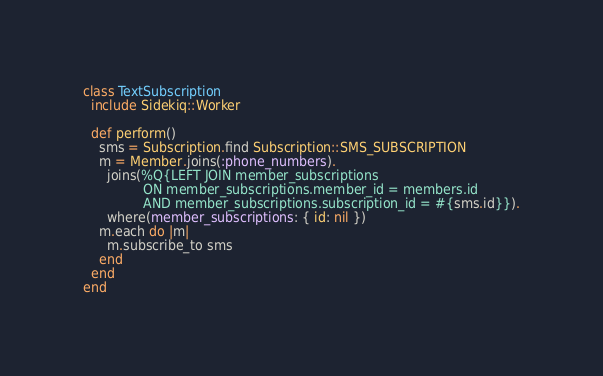Convert code to text. <code><loc_0><loc_0><loc_500><loc_500><_Ruby_>class TextSubscription
  include Sidekiq::Worker

  def perform()
    sms = Subscription.find Subscription::SMS_SUBSCRIPTION
    m = Member.joins(:phone_numbers).
      joins(%Q{LEFT JOIN member_subscriptions
               ON member_subscriptions.member_id = members.id
               AND member_subscriptions.subscription_id = #{sms.id}}).
      where(member_subscriptions: { id: nil })
    m.each do |m|
      m.subscribe_to sms
    end
  end
end
</code> 